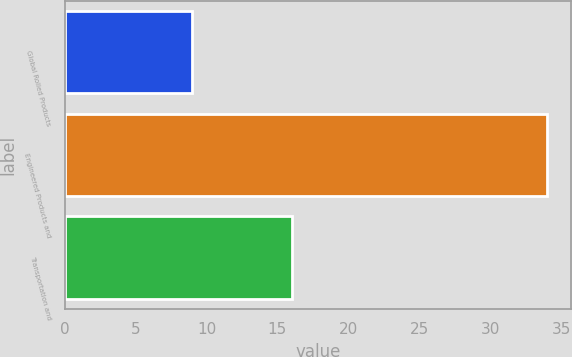Convert chart to OTSL. <chart><loc_0><loc_0><loc_500><loc_500><bar_chart><fcel>Global Rolled Products<fcel>Engineered Products and<fcel>Transportation and<nl><fcel>9<fcel>34<fcel>16<nl></chart> 